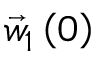Convert formula to latex. <formula><loc_0><loc_0><loc_500><loc_500>\vec { w } _ { 1 } \left ( 0 \right )</formula> 